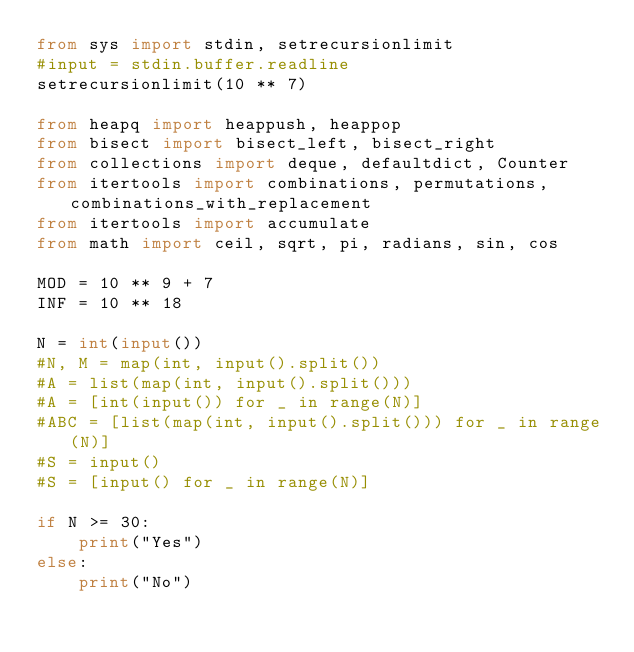<code> <loc_0><loc_0><loc_500><loc_500><_Python_>from sys import stdin, setrecursionlimit
#input = stdin.buffer.readline
setrecursionlimit(10 ** 7)

from heapq import heappush, heappop
from bisect import bisect_left, bisect_right
from collections import deque, defaultdict, Counter
from itertools import combinations, permutations, combinations_with_replacement
from itertools import accumulate
from math import ceil, sqrt, pi, radians, sin, cos

MOD = 10 ** 9 + 7
INF = 10 ** 18

N = int(input())
#N, M = map(int, input().split())
#A = list(map(int, input().split()))
#A = [int(input()) for _ in range(N)]
#ABC = [list(map(int, input().split())) for _ in range(N)]
#S = input()
#S = [input() for _ in range(N)]

if N >= 30:
    print("Yes")
else:
    print("No")</code> 